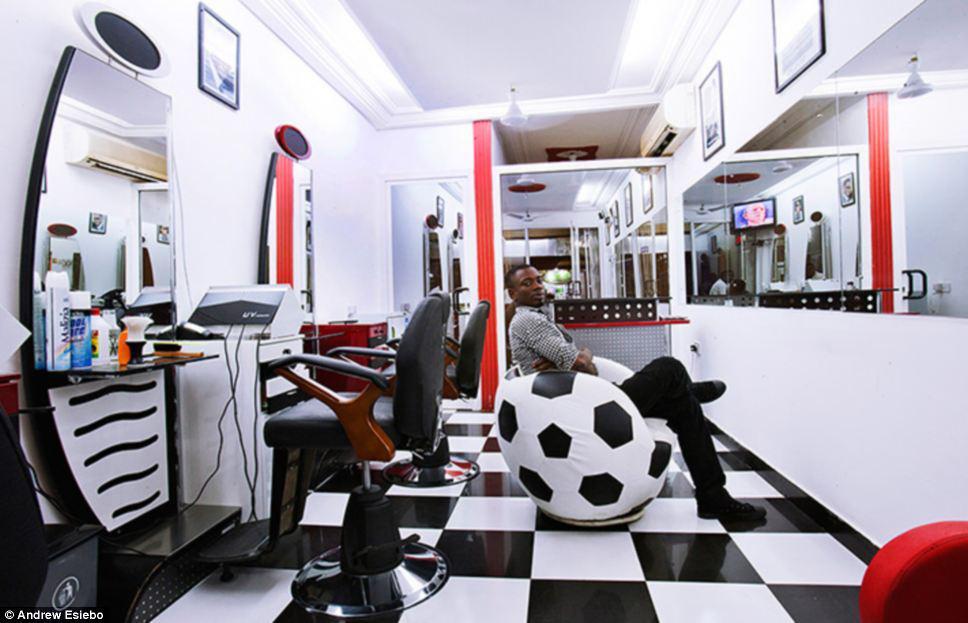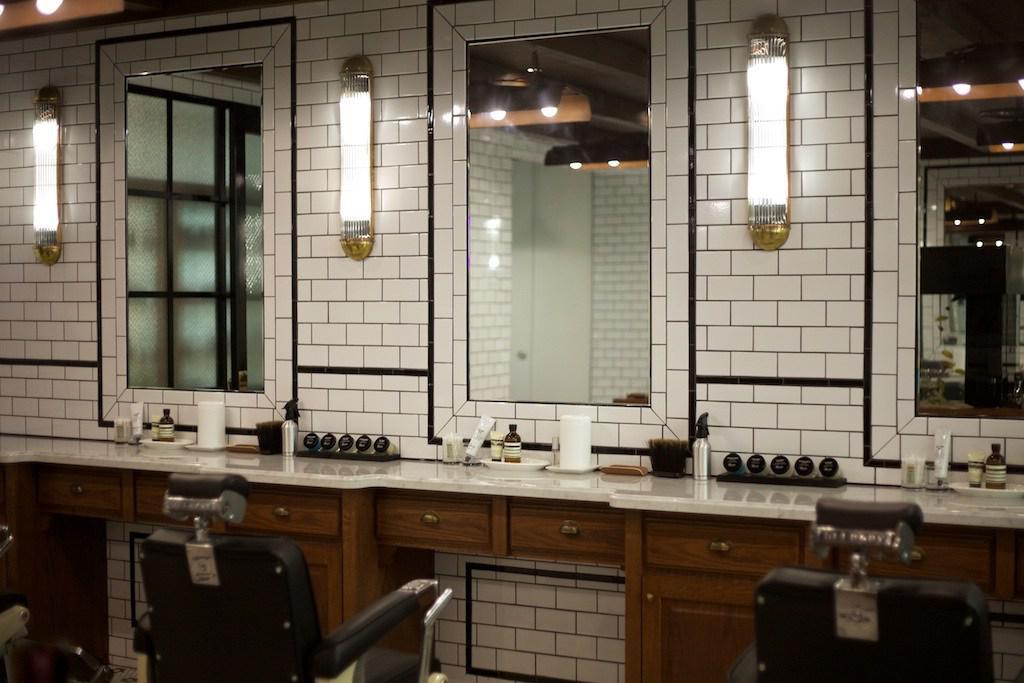The first image is the image on the left, the second image is the image on the right. For the images displayed, is the sentence "In at least one image there are three square mirrors." factually correct? Answer yes or no. Yes. The first image is the image on the left, the second image is the image on the right. For the images displayed, is the sentence "A floor has a checkered pattern." factually correct? Answer yes or no. Yes. 